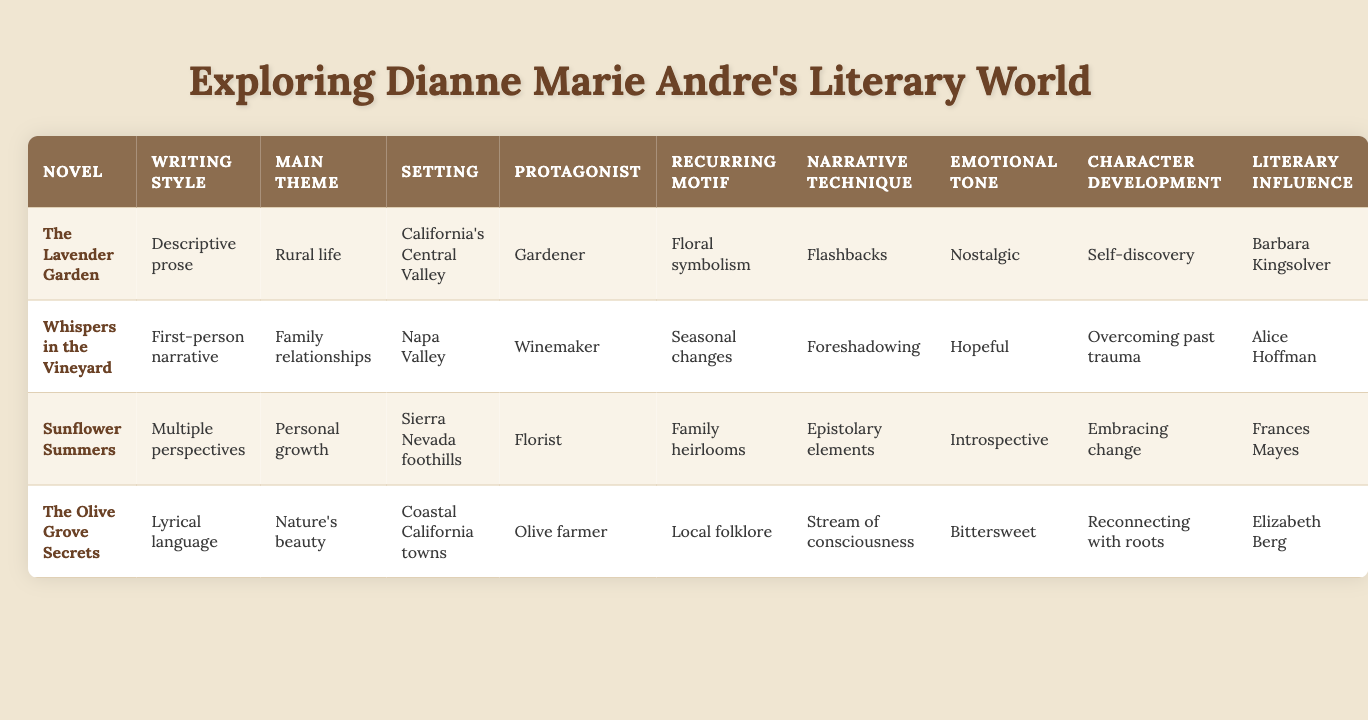What writing style is used in "Sunflower Summers"? The table shows that "Sunflower Summers" employs a "Multiple perspectives" writing style.
Answer: Multiple perspectives Which novel has a protagonist that is a winemaker? According to the table, "Whispers in the Vineyard" features a winemaker as the protagonist.
Answer: Whispers in the Vineyard What is the main theme of "The Lavender Garden"? The table indicates that "The Lavender Garden" focuses on the theme of "Rural life."
Answer: Rural life How many novels use "Descriptive prose" as a writing style? By inspecting the table, only one novel, "The Lavender Garden," is listed with "Descriptive prose."
Answer: 1 Is "Family heirlooms" a recurring motif in "Sunflower Summers"? The table shows that "Family heirlooms" is not listed as a recurring motif for "Sunflower Summers," hence the answer is no.
Answer: No What is the emotional tone of "The Olive Grove Secrets"? The table indicates that the emotional tone for "The Olive Grove Secrets" is "Bittersweet."
Answer: Bittersweet Which novel combines the themes of "Personal growth" and "Nature's beauty"? The table indicates that "Sunflower Summers" is associated with "Personal growth," but not with "Nature's beauty." However, "The Olive Grove Secrets" has a direct connection with both themes.
Answer: The Olive Grove Secrets What techniques are used in "The Lavender Garden"? The table shows that "The Lavender Garden" employs "Flashbacks" as its narrative technique.
Answer: Flashbacks In which setting does the "Olive farmer" protagonist work? The table indicates that the "Olive farmer" protagonist is found in "Coastal California towns."
Answer: Coastal California towns Which novel is influenced by Barbara Kingsolver? According to the table, "The Lavender Garden" is influenced by Barbara Kingsolver.
Answer: The Lavender Garden What are the main themes of the novels in this table? The table lists four themes: "Rural life," "Family relationships," "Personal growth," and "Nature's beauty," which are associated with the respective novels.
Answer: Rural life, Family relationships, Personal growth, Nature's beauty Which narrative techniques are used across all novels? The table shows different techniques for each novel, and each novel uses either "Flashbacks," "Foreshadowing," "Epistolary elements," or "Stream of consciousness," indicating no common narrative technique across all novels.
Answer: None How many novels feature "Introspective" as an emotional tone? By examining the table, only "Sunflower Summers" is specified as having an "Introspective" emotional tone.
Answer: 1 What occupations do the protagonists of "The Lavender Garden" and "Whispers in the Vineyard" hold? Referring to the table, the protagonists are a "Gardener" in "The Lavender Garden" and a "Winemaker" in "Whispers in the Vineyard."
Answer: Gardener and Winemaker Which novel features "Seasonal changes" as a recurring motif? Looking at the table, "Sunflower Summers" is identified to have "Seasonal changes" as a recurring motif.
Answer: Sunflower Summers Are all novels set in California? The table explicitly shows that all novels are set in various locations within California, confirming that the answer is yes.
Answer: Yes 